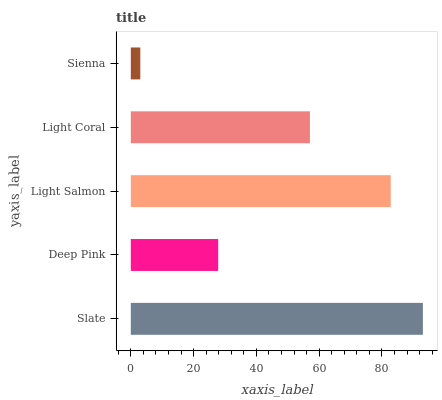Is Sienna the minimum?
Answer yes or no. Yes. Is Slate the maximum?
Answer yes or no. Yes. Is Deep Pink the minimum?
Answer yes or no. No. Is Deep Pink the maximum?
Answer yes or no. No. Is Slate greater than Deep Pink?
Answer yes or no. Yes. Is Deep Pink less than Slate?
Answer yes or no. Yes. Is Deep Pink greater than Slate?
Answer yes or no. No. Is Slate less than Deep Pink?
Answer yes or no. No. Is Light Coral the high median?
Answer yes or no. Yes. Is Light Coral the low median?
Answer yes or no. Yes. Is Sienna the high median?
Answer yes or no. No. Is Slate the low median?
Answer yes or no. No. 